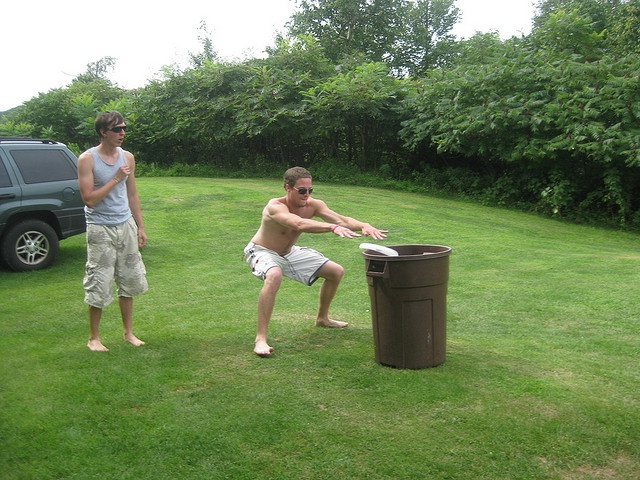Describe the objects in this image and their specific colors. I can see people in white, darkgray, and gray tones, people in white, lightgray, and gray tones, car in white, gray, black, and purple tones, and frisbee in white, darkgray, gray, and olive tones in this image. 